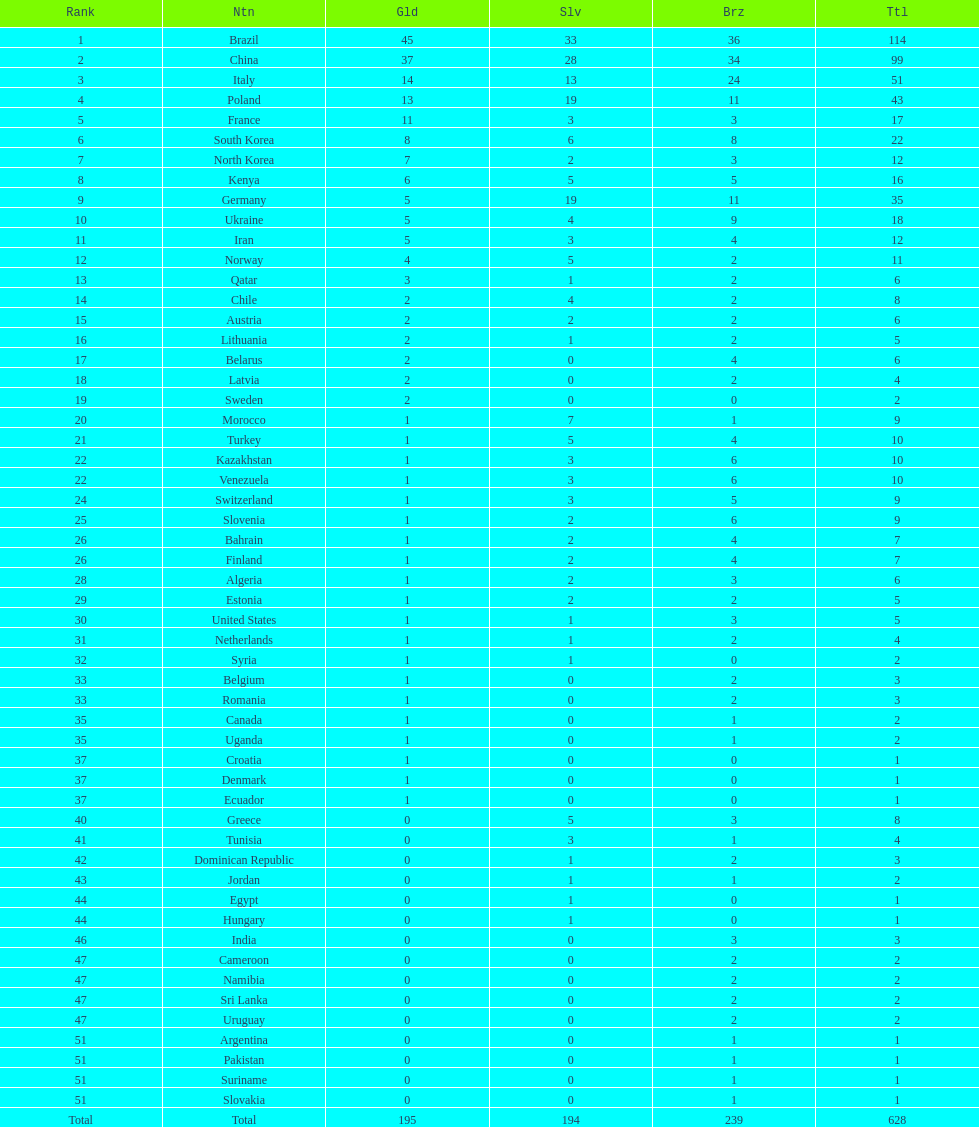Who won more gold medals, brazil or china? Brazil. 